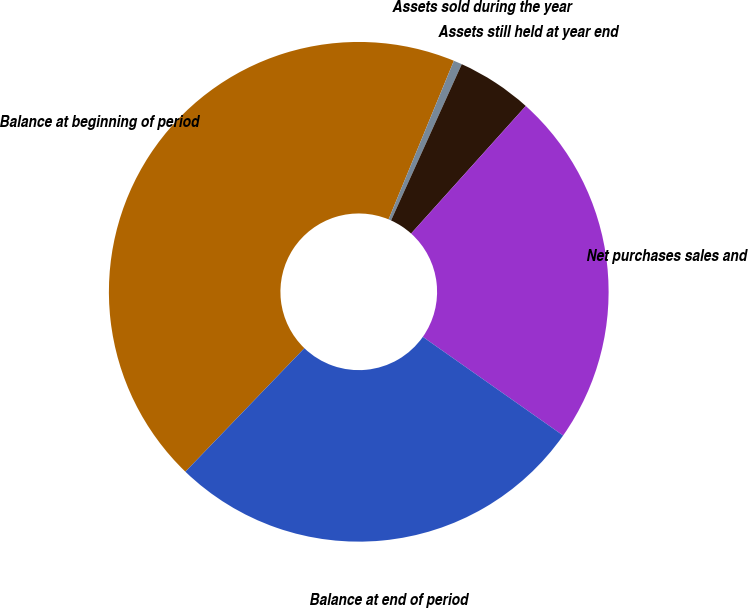<chart> <loc_0><loc_0><loc_500><loc_500><pie_chart><fcel>Balance at beginning of period<fcel>Assets sold during the year<fcel>Assets still held at year end<fcel>Net purchases sales and<fcel>Balance at end of period<nl><fcel>44.01%<fcel>0.55%<fcel>4.89%<fcel>23.1%<fcel>27.45%<nl></chart> 